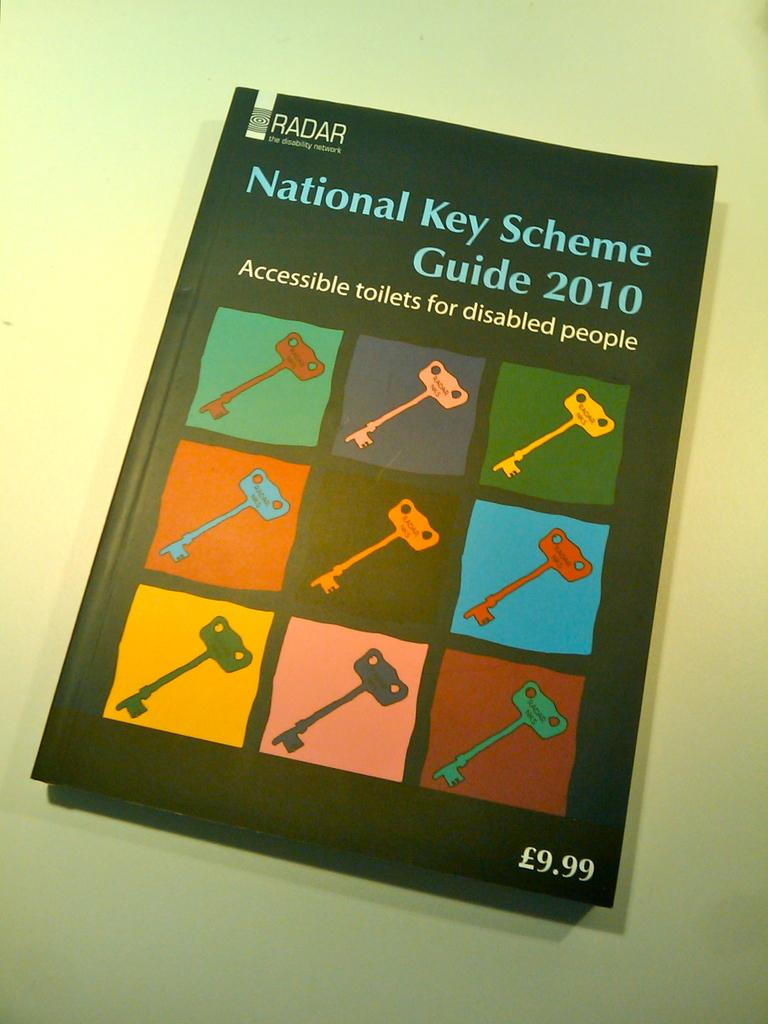<image>
Present a compact description of the photo's key features. black book titled national key scheme guide 2010 with 9 pictures keys on the cover 